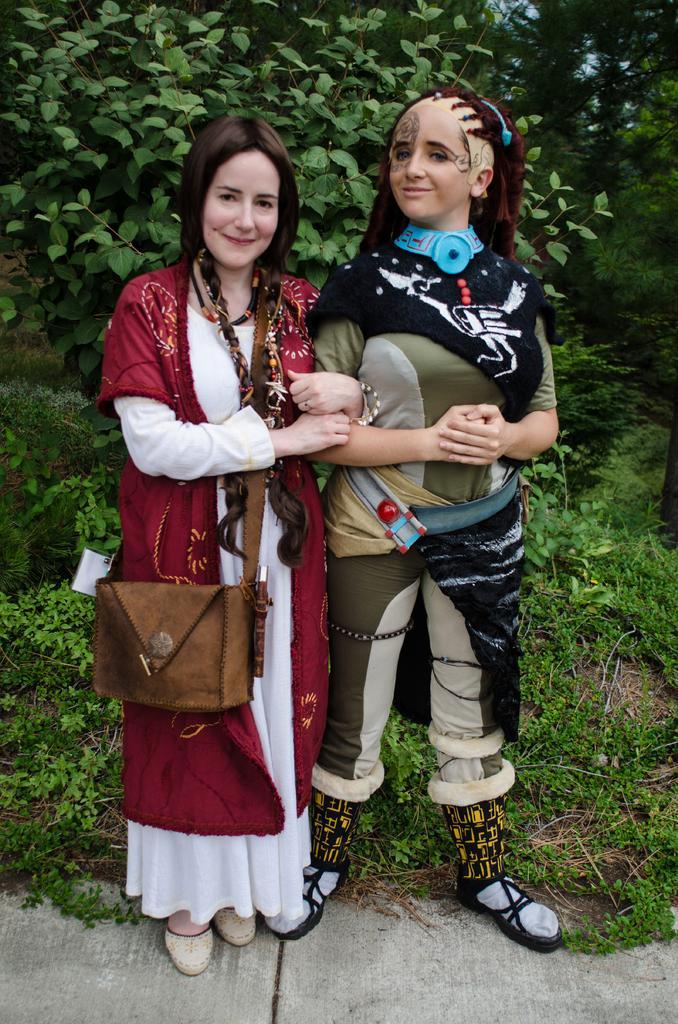How would you summarize this image in a sentence or two? This image consists of plants on the top. There are two persons standing, both of them are women. Right side one is wearing green and black dress. Left side one is wearing white and maroon dress, she is holding a bag. 